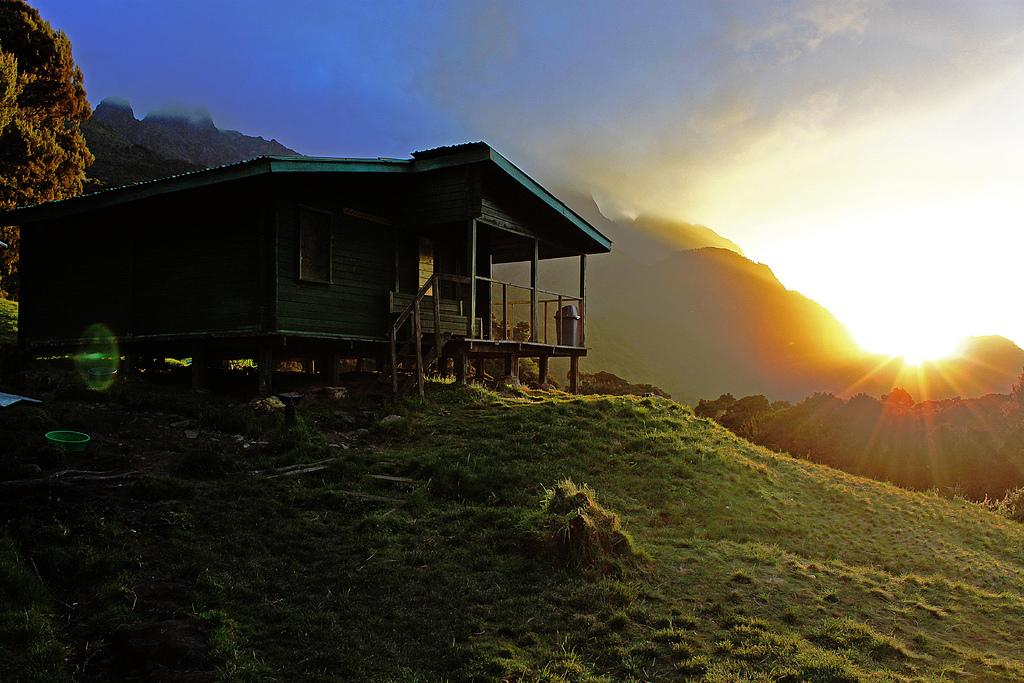What type of house is in the image? There is a wooden house in the image. What is the ground like around the house? The house is placed on a green ground. What can be seen in the distance behind the house? There are mountains in the background of the image. Where is the sun located in the image? The sun is visible in the right corner of the image. How does the wooden house pull the mountains closer in the image? The wooden house does not pull the mountains closer in the image; it is a stationary structure on the green ground. 